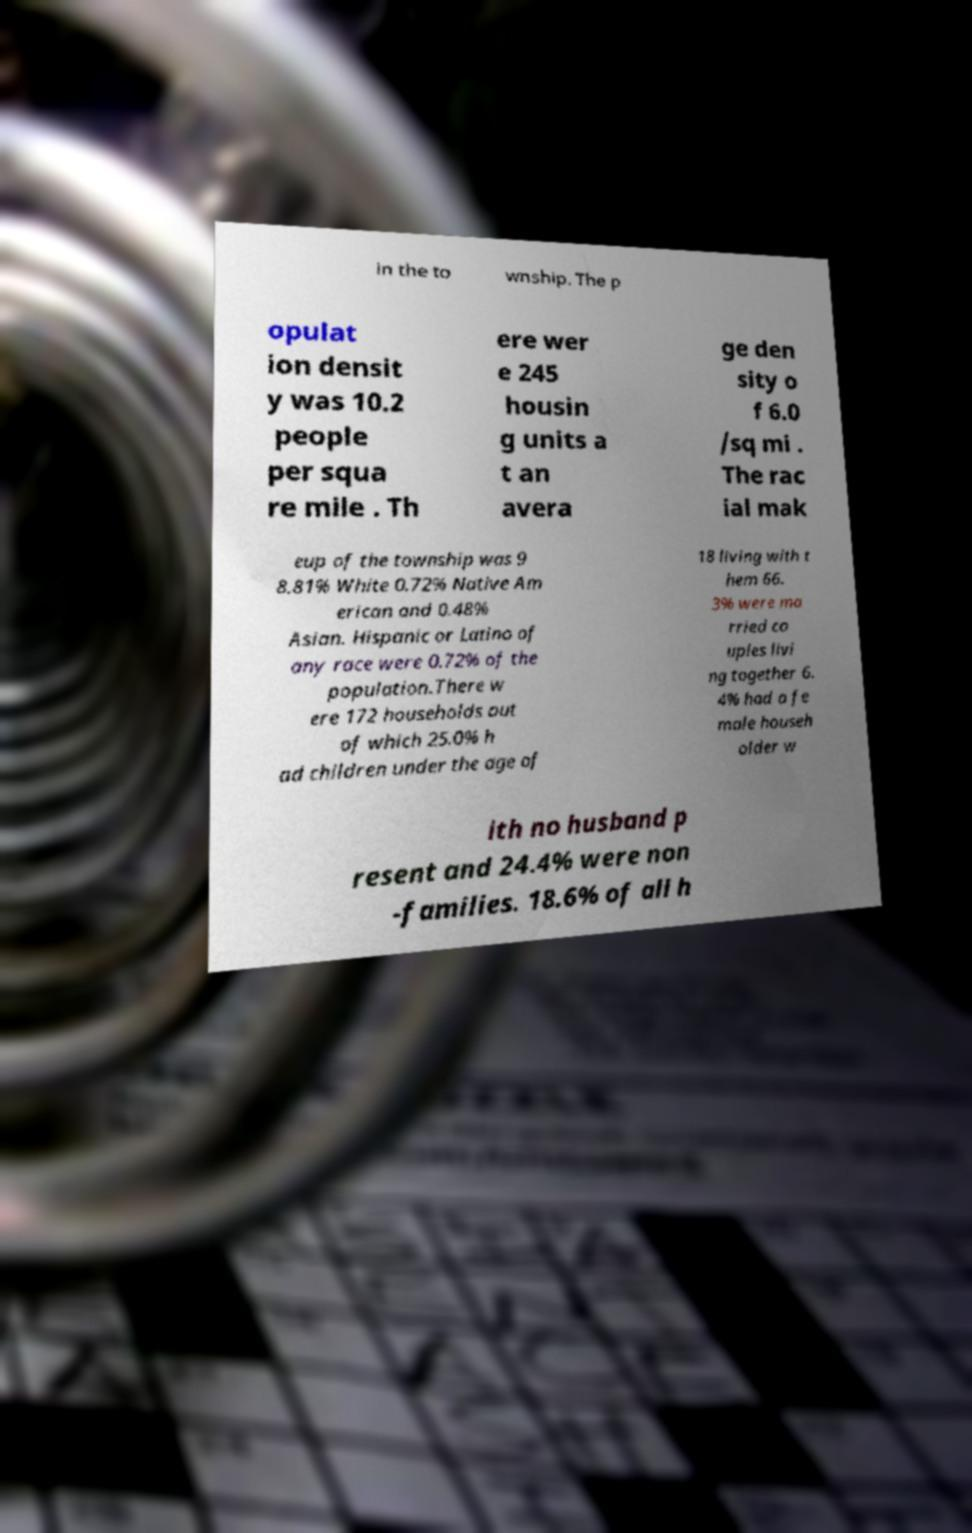I need the written content from this picture converted into text. Can you do that? in the to wnship. The p opulat ion densit y was 10.2 people per squa re mile . Th ere wer e 245 housin g units a t an avera ge den sity o f 6.0 /sq mi . The rac ial mak eup of the township was 9 8.81% White 0.72% Native Am erican and 0.48% Asian. Hispanic or Latino of any race were 0.72% of the population.There w ere 172 households out of which 25.0% h ad children under the age of 18 living with t hem 66. 3% were ma rried co uples livi ng together 6. 4% had a fe male househ older w ith no husband p resent and 24.4% were non -families. 18.6% of all h 